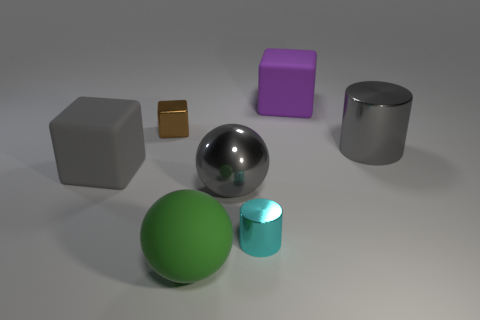Subtract all large cubes. How many cubes are left? 1 Add 3 big purple matte objects. How many objects exist? 10 Subtract all cubes. How many objects are left? 4 Subtract all tiny yellow blocks. Subtract all brown metal blocks. How many objects are left? 6 Add 6 big gray blocks. How many big gray blocks are left? 7 Add 1 large metal things. How many large metal things exist? 3 Subtract 1 brown blocks. How many objects are left? 6 Subtract all gray cylinders. Subtract all gray balls. How many cylinders are left? 1 